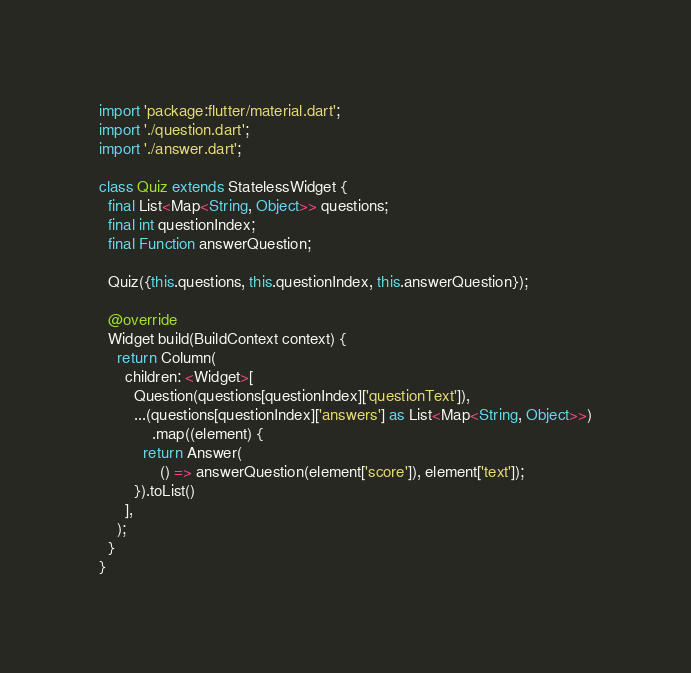<code> <loc_0><loc_0><loc_500><loc_500><_Dart_>import 'package:flutter/material.dart';
import './question.dart';
import './answer.dart';

class Quiz extends StatelessWidget {
  final List<Map<String, Object>> questions;
  final int questionIndex;
  final Function answerQuestion;

  Quiz({this.questions, this.questionIndex, this.answerQuestion});

  @override
  Widget build(BuildContext context) {
    return Column(
      children: <Widget>[
        Question(questions[questionIndex]['questionText']),
        ...(questions[questionIndex]['answers'] as List<Map<String, Object>>)
            .map((element) {
          return Answer(
              () => answerQuestion(element['score']), element['text']);
        }).toList()
      ],
    );
  }
}
</code> 